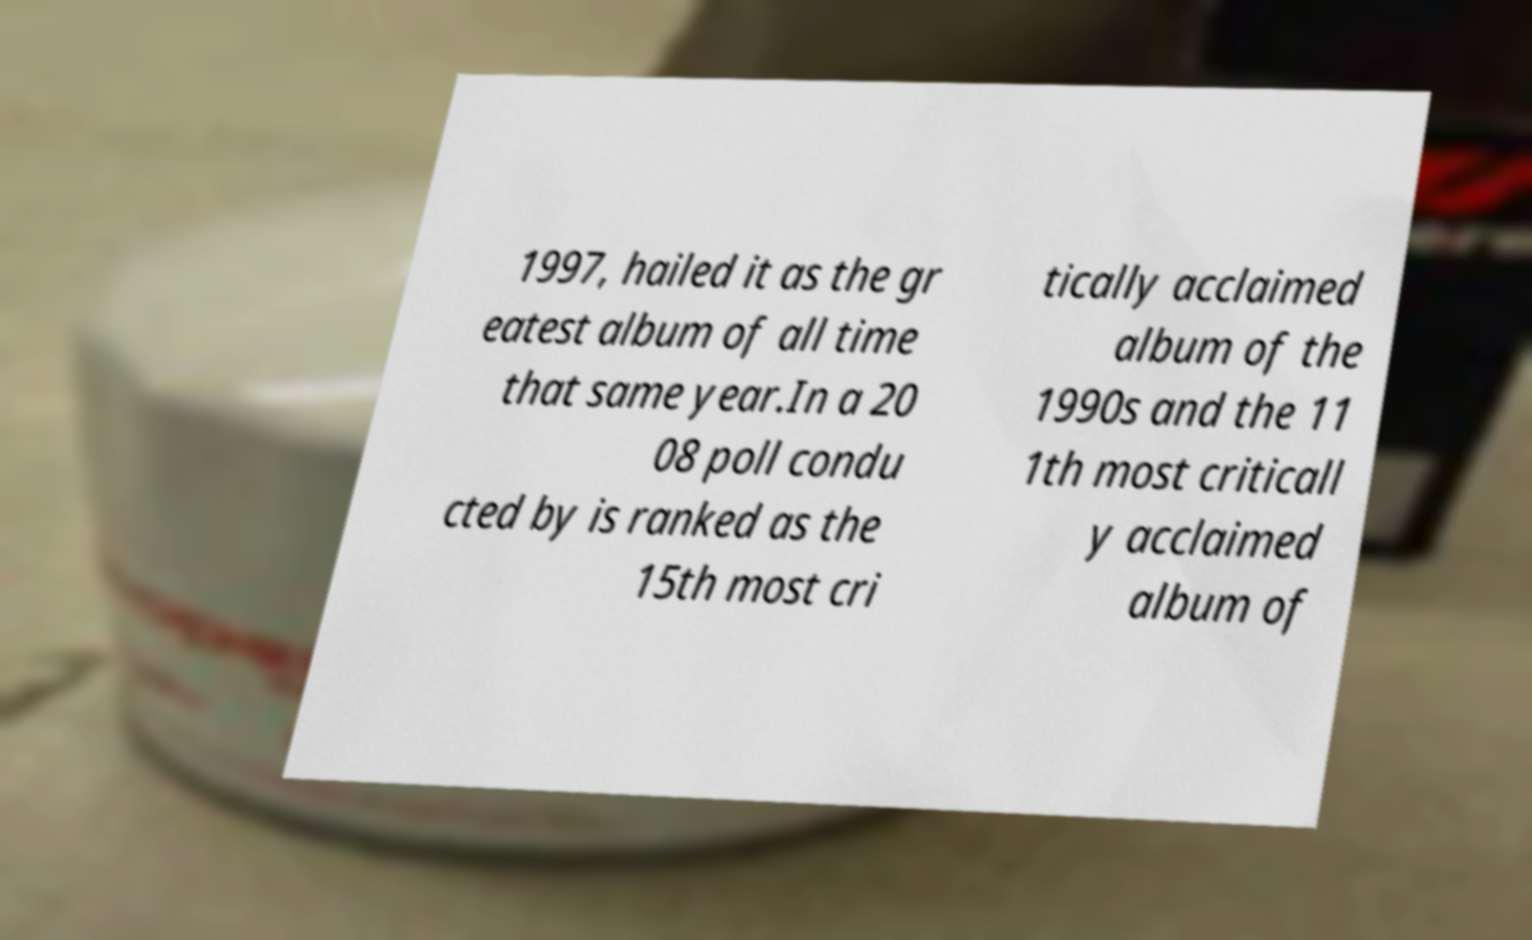Could you assist in decoding the text presented in this image and type it out clearly? 1997, hailed it as the gr eatest album of all time that same year.In a 20 08 poll condu cted by is ranked as the 15th most cri tically acclaimed album of the 1990s and the 11 1th most criticall y acclaimed album of 